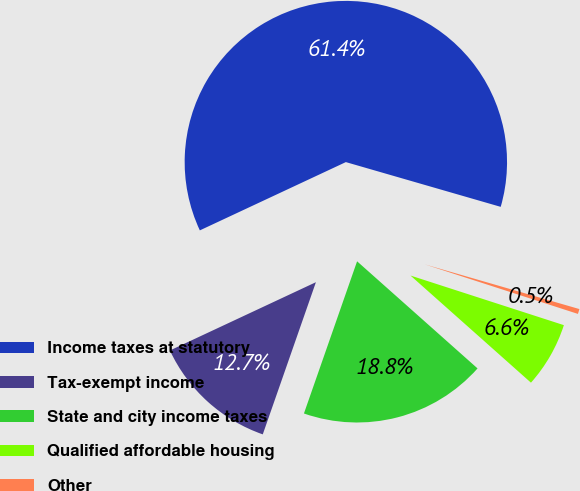Convert chart. <chart><loc_0><loc_0><loc_500><loc_500><pie_chart><fcel>Income taxes at statutory<fcel>Tax-exempt income<fcel>State and city income taxes<fcel>Qualified affordable housing<fcel>Other<nl><fcel>61.44%<fcel>12.69%<fcel>18.78%<fcel>6.59%<fcel>0.5%<nl></chart> 